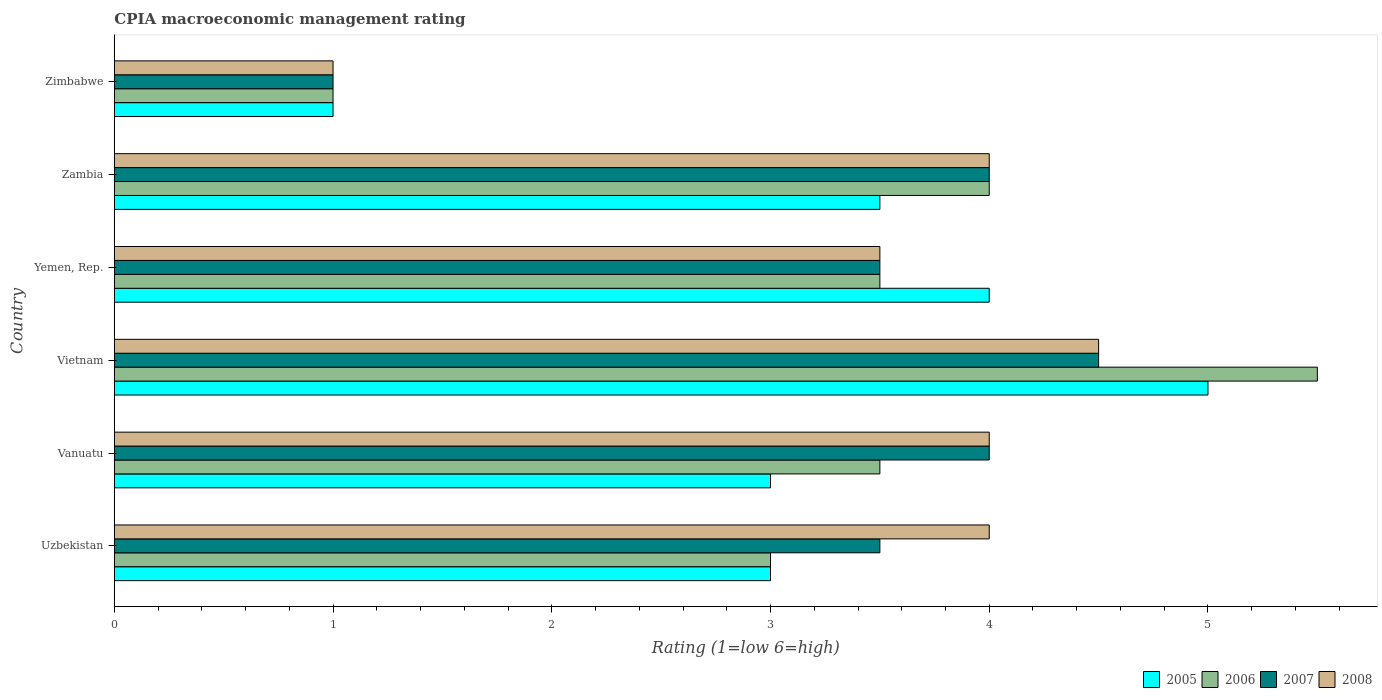How many groups of bars are there?
Offer a very short reply. 6. Are the number of bars per tick equal to the number of legend labels?
Keep it short and to the point. Yes. How many bars are there on the 2nd tick from the bottom?
Ensure brevity in your answer.  4. What is the label of the 3rd group of bars from the top?
Offer a terse response. Yemen, Rep. What is the CPIA rating in 2008 in Uzbekistan?
Your answer should be very brief. 4. Across all countries, what is the maximum CPIA rating in 2005?
Ensure brevity in your answer.  5. Across all countries, what is the minimum CPIA rating in 2006?
Give a very brief answer. 1. In which country was the CPIA rating in 2005 maximum?
Provide a succinct answer. Vietnam. In which country was the CPIA rating in 2006 minimum?
Provide a succinct answer. Zimbabwe. What is the difference between the CPIA rating in 2006 in Yemen, Rep. and that in Zambia?
Your response must be concise. -0.5. What is the average CPIA rating in 2007 per country?
Offer a very short reply. 3.42. What is the difference between the CPIA rating in 2006 and CPIA rating in 2008 in Uzbekistan?
Your answer should be compact. -1. Is the CPIA rating in 2006 in Uzbekistan less than that in Vanuatu?
Keep it short and to the point. Yes. What is the difference between the highest and the second highest CPIA rating in 2006?
Make the answer very short. 1.5. What is the difference between the highest and the lowest CPIA rating in 2005?
Offer a very short reply. 4. Is the sum of the CPIA rating in 2008 in Uzbekistan and Vanuatu greater than the maximum CPIA rating in 2005 across all countries?
Give a very brief answer. Yes. What does the 2nd bar from the top in Zimbabwe represents?
Provide a short and direct response. 2007. What does the 2nd bar from the bottom in Zambia represents?
Provide a short and direct response. 2006. Are all the bars in the graph horizontal?
Keep it short and to the point. Yes. Are the values on the major ticks of X-axis written in scientific E-notation?
Provide a succinct answer. No. Where does the legend appear in the graph?
Provide a short and direct response. Bottom right. How many legend labels are there?
Give a very brief answer. 4. What is the title of the graph?
Offer a very short reply. CPIA macroeconomic management rating. What is the label or title of the X-axis?
Your response must be concise. Rating (1=low 6=high). What is the Rating (1=low 6=high) in 2007 in Uzbekistan?
Make the answer very short. 3.5. What is the Rating (1=low 6=high) in 2006 in Vanuatu?
Your answer should be very brief. 3.5. What is the Rating (1=low 6=high) of 2007 in Vanuatu?
Provide a succinct answer. 4. What is the Rating (1=low 6=high) in 2008 in Vanuatu?
Your response must be concise. 4. What is the Rating (1=low 6=high) of 2005 in Vietnam?
Provide a short and direct response. 5. What is the Rating (1=low 6=high) of 2006 in Vietnam?
Provide a succinct answer. 5.5. What is the Rating (1=low 6=high) of 2007 in Vietnam?
Give a very brief answer. 4.5. What is the Rating (1=low 6=high) in 2008 in Vietnam?
Keep it short and to the point. 4.5. What is the Rating (1=low 6=high) in 2005 in Yemen, Rep.?
Keep it short and to the point. 4. What is the Rating (1=low 6=high) in 2006 in Yemen, Rep.?
Your answer should be very brief. 3.5. What is the Rating (1=low 6=high) of 2007 in Yemen, Rep.?
Provide a short and direct response. 3.5. What is the Rating (1=low 6=high) in 2007 in Zambia?
Make the answer very short. 4. What is the Rating (1=low 6=high) of 2008 in Zambia?
Keep it short and to the point. 4. What is the Rating (1=low 6=high) of 2005 in Zimbabwe?
Your response must be concise. 1. What is the Rating (1=low 6=high) of 2007 in Zimbabwe?
Offer a terse response. 1. What is the Rating (1=low 6=high) of 2008 in Zimbabwe?
Provide a short and direct response. 1. Across all countries, what is the maximum Rating (1=low 6=high) of 2005?
Your answer should be compact. 5. Across all countries, what is the maximum Rating (1=low 6=high) in 2008?
Keep it short and to the point. 4.5. Across all countries, what is the minimum Rating (1=low 6=high) in 2007?
Offer a very short reply. 1. Across all countries, what is the minimum Rating (1=low 6=high) of 2008?
Offer a very short reply. 1. What is the total Rating (1=low 6=high) of 2008 in the graph?
Provide a succinct answer. 21. What is the difference between the Rating (1=low 6=high) in 2005 in Uzbekistan and that in Vanuatu?
Provide a succinct answer. 0. What is the difference between the Rating (1=low 6=high) of 2006 in Uzbekistan and that in Vanuatu?
Provide a succinct answer. -0.5. What is the difference between the Rating (1=low 6=high) of 2007 in Uzbekistan and that in Vanuatu?
Your answer should be very brief. -0.5. What is the difference between the Rating (1=low 6=high) in 2008 in Uzbekistan and that in Vanuatu?
Make the answer very short. 0. What is the difference between the Rating (1=low 6=high) in 2006 in Uzbekistan and that in Vietnam?
Offer a very short reply. -2.5. What is the difference between the Rating (1=low 6=high) of 2006 in Uzbekistan and that in Yemen, Rep.?
Your answer should be very brief. -0.5. What is the difference between the Rating (1=low 6=high) of 2005 in Uzbekistan and that in Zambia?
Make the answer very short. -0.5. What is the difference between the Rating (1=low 6=high) of 2006 in Uzbekistan and that in Zambia?
Offer a very short reply. -1. What is the difference between the Rating (1=low 6=high) of 2005 in Uzbekistan and that in Zimbabwe?
Your answer should be very brief. 2. What is the difference between the Rating (1=low 6=high) of 2007 in Uzbekistan and that in Zimbabwe?
Your answer should be compact. 2.5. What is the difference between the Rating (1=low 6=high) in 2008 in Uzbekistan and that in Zimbabwe?
Your answer should be compact. 3. What is the difference between the Rating (1=low 6=high) in 2005 in Vanuatu and that in Yemen, Rep.?
Ensure brevity in your answer.  -1. What is the difference between the Rating (1=low 6=high) of 2005 in Vanuatu and that in Zambia?
Make the answer very short. -0.5. What is the difference between the Rating (1=low 6=high) of 2007 in Vanuatu and that in Zambia?
Ensure brevity in your answer.  0. What is the difference between the Rating (1=low 6=high) in 2008 in Vanuatu and that in Zambia?
Offer a very short reply. 0. What is the difference between the Rating (1=low 6=high) in 2005 in Vanuatu and that in Zimbabwe?
Ensure brevity in your answer.  2. What is the difference between the Rating (1=low 6=high) in 2006 in Vanuatu and that in Zimbabwe?
Make the answer very short. 2.5. What is the difference between the Rating (1=low 6=high) of 2008 in Vanuatu and that in Zimbabwe?
Make the answer very short. 3. What is the difference between the Rating (1=low 6=high) of 2007 in Vietnam and that in Yemen, Rep.?
Your answer should be compact. 1. What is the difference between the Rating (1=low 6=high) of 2007 in Vietnam and that in Zambia?
Keep it short and to the point. 0.5. What is the difference between the Rating (1=low 6=high) in 2008 in Vietnam and that in Zambia?
Provide a succinct answer. 0.5. What is the difference between the Rating (1=low 6=high) in 2006 in Vietnam and that in Zimbabwe?
Ensure brevity in your answer.  4.5. What is the difference between the Rating (1=low 6=high) in 2008 in Vietnam and that in Zimbabwe?
Provide a short and direct response. 3.5. What is the difference between the Rating (1=low 6=high) in 2008 in Yemen, Rep. and that in Zambia?
Your answer should be very brief. -0.5. What is the difference between the Rating (1=low 6=high) in 2007 in Yemen, Rep. and that in Zimbabwe?
Offer a terse response. 2.5. What is the difference between the Rating (1=low 6=high) in 2008 in Yemen, Rep. and that in Zimbabwe?
Your response must be concise. 2.5. What is the difference between the Rating (1=low 6=high) in 2005 in Uzbekistan and the Rating (1=low 6=high) in 2007 in Vanuatu?
Your response must be concise. -1. What is the difference between the Rating (1=low 6=high) in 2006 in Uzbekistan and the Rating (1=low 6=high) in 2007 in Vanuatu?
Provide a succinct answer. -1. What is the difference between the Rating (1=low 6=high) of 2007 in Uzbekistan and the Rating (1=low 6=high) of 2008 in Vanuatu?
Offer a very short reply. -0.5. What is the difference between the Rating (1=low 6=high) of 2005 in Uzbekistan and the Rating (1=low 6=high) of 2007 in Vietnam?
Offer a terse response. -1.5. What is the difference between the Rating (1=low 6=high) in 2006 in Uzbekistan and the Rating (1=low 6=high) in 2007 in Vietnam?
Offer a very short reply. -1.5. What is the difference between the Rating (1=low 6=high) of 2005 in Uzbekistan and the Rating (1=low 6=high) of 2007 in Yemen, Rep.?
Give a very brief answer. -0.5. What is the difference between the Rating (1=low 6=high) of 2005 in Uzbekistan and the Rating (1=low 6=high) of 2008 in Yemen, Rep.?
Give a very brief answer. -0.5. What is the difference between the Rating (1=low 6=high) in 2006 in Uzbekistan and the Rating (1=low 6=high) in 2007 in Yemen, Rep.?
Provide a succinct answer. -0.5. What is the difference between the Rating (1=low 6=high) of 2007 in Uzbekistan and the Rating (1=low 6=high) of 2008 in Yemen, Rep.?
Your answer should be very brief. 0. What is the difference between the Rating (1=low 6=high) of 2005 in Uzbekistan and the Rating (1=low 6=high) of 2008 in Zambia?
Give a very brief answer. -1. What is the difference between the Rating (1=low 6=high) of 2006 in Uzbekistan and the Rating (1=low 6=high) of 2008 in Zambia?
Keep it short and to the point. -1. What is the difference between the Rating (1=low 6=high) of 2007 in Uzbekistan and the Rating (1=low 6=high) of 2008 in Zambia?
Your answer should be very brief. -0.5. What is the difference between the Rating (1=low 6=high) in 2005 in Uzbekistan and the Rating (1=low 6=high) in 2007 in Zimbabwe?
Provide a short and direct response. 2. What is the difference between the Rating (1=low 6=high) of 2005 in Uzbekistan and the Rating (1=low 6=high) of 2008 in Zimbabwe?
Your answer should be very brief. 2. What is the difference between the Rating (1=low 6=high) of 2006 in Uzbekistan and the Rating (1=low 6=high) of 2007 in Zimbabwe?
Give a very brief answer. 2. What is the difference between the Rating (1=low 6=high) of 2007 in Uzbekistan and the Rating (1=low 6=high) of 2008 in Zimbabwe?
Ensure brevity in your answer.  2.5. What is the difference between the Rating (1=low 6=high) of 2005 in Vanuatu and the Rating (1=low 6=high) of 2007 in Vietnam?
Offer a very short reply. -1.5. What is the difference between the Rating (1=low 6=high) of 2005 in Vanuatu and the Rating (1=low 6=high) of 2008 in Vietnam?
Give a very brief answer. -1.5. What is the difference between the Rating (1=low 6=high) of 2005 in Vanuatu and the Rating (1=low 6=high) of 2006 in Yemen, Rep.?
Your answer should be very brief. -0.5. What is the difference between the Rating (1=low 6=high) in 2006 in Vanuatu and the Rating (1=low 6=high) in 2007 in Yemen, Rep.?
Make the answer very short. 0. What is the difference between the Rating (1=low 6=high) in 2006 in Vanuatu and the Rating (1=low 6=high) in 2008 in Yemen, Rep.?
Provide a short and direct response. 0. What is the difference between the Rating (1=low 6=high) in 2007 in Vanuatu and the Rating (1=low 6=high) in 2008 in Yemen, Rep.?
Offer a terse response. 0.5. What is the difference between the Rating (1=low 6=high) of 2006 in Vanuatu and the Rating (1=low 6=high) of 2008 in Zimbabwe?
Make the answer very short. 2.5. What is the difference between the Rating (1=low 6=high) of 2007 in Vanuatu and the Rating (1=low 6=high) of 2008 in Zimbabwe?
Provide a short and direct response. 3. What is the difference between the Rating (1=low 6=high) of 2005 in Vietnam and the Rating (1=low 6=high) of 2007 in Yemen, Rep.?
Your answer should be compact. 1.5. What is the difference between the Rating (1=low 6=high) of 2006 in Vietnam and the Rating (1=low 6=high) of 2007 in Yemen, Rep.?
Your answer should be compact. 2. What is the difference between the Rating (1=low 6=high) in 2006 in Vietnam and the Rating (1=low 6=high) in 2008 in Yemen, Rep.?
Your response must be concise. 2. What is the difference between the Rating (1=low 6=high) of 2007 in Vietnam and the Rating (1=low 6=high) of 2008 in Yemen, Rep.?
Provide a succinct answer. 1. What is the difference between the Rating (1=low 6=high) of 2006 in Vietnam and the Rating (1=low 6=high) of 2007 in Zambia?
Provide a short and direct response. 1.5. What is the difference between the Rating (1=low 6=high) of 2006 in Vietnam and the Rating (1=low 6=high) of 2007 in Zimbabwe?
Your answer should be compact. 4.5. What is the difference between the Rating (1=low 6=high) of 2005 in Yemen, Rep. and the Rating (1=low 6=high) of 2006 in Zambia?
Offer a very short reply. 0. What is the difference between the Rating (1=low 6=high) of 2005 in Yemen, Rep. and the Rating (1=low 6=high) of 2007 in Zambia?
Your response must be concise. 0. What is the difference between the Rating (1=low 6=high) in 2006 in Yemen, Rep. and the Rating (1=low 6=high) in 2007 in Zambia?
Keep it short and to the point. -0.5. What is the difference between the Rating (1=low 6=high) in 2006 in Yemen, Rep. and the Rating (1=low 6=high) in 2008 in Zambia?
Ensure brevity in your answer.  -0.5. What is the difference between the Rating (1=low 6=high) of 2007 in Yemen, Rep. and the Rating (1=low 6=high) of 2008 in Zambia?
Offer a terse response. -0.5. What is the difference between the Rating (1=low 6=high) in 2005 in Yemen, Rep. and the Rating (1=low 6=high) in 2007 in Zimbabwe?
Your answer should be very brief. 3. What is the difference between the Rating (1=low 6=high) of 2005 in Yemen, Rep. and the Rating (1=low 6=high) of 2008 in Zimbabwe?
Your response must be concise. 3. What is the difference between the Rating (1=low 6=high) of 2006 in Yemen, Rep. and the Rating (1=low 6=high) of 2008 in Zimbabwe?
Provide a short and direct response. 2.5. What is the difference between the Rating (1=low 6=high) in 2005 in Zambia and the Rating (1=low 6=high) in 2006 in Zimbabwe?
Offer a very short reply. 2.5. What is the difference between the Rating (1=low 6=high) in 2005 in Zambia and the Rating (1=low 6=high) in 2008 in Zimbabwe?
Offer a terse response. 2.5. What is the difference between the Rating (1=low 6=high) of 2006 in Zambia and the Rating (1=low 6=high) of 2007 in Zimbabwe?
Offer a very short reply. 3. What is the difference between the Rating (1=low 6=high) in 2007 in Zambia and the Rating (1=low 6=high) in 2008 in Zimbabwe?
Your answer should be compact. 3. What is the average Rating (1=low 6=high) of 2005 per country?
Ensure brevity in your answer.  3.25. What is the average Rating (1=low 6=high) of 2006 per country?
Offer a terse response. 3.42. What is the average Rating (1=low 6=high) of 2007 per country?
Give a very brief answer. 3.42. What is the difference between the Rating (1=low 6=high) in 2005 and Rating (1=low 6=high) in 2006 in Uzbekistan?
Your answer should be very brief. 0. What is the difference between the Rating (1=low 6=high) in 2005 and Rating (1=low 6=high) in 2008 in Uzbekistan?
Your answer should be very brief. -1. What is the difference between the Rating (1=low 6=high) of 2006 and Rating (1=low 6=high) of 2007 in Uzbekistan?
Ensure brevity in your answer.  -0.5. What is the difference between the Rating (1=low 6=high) of 2006 and Rating (1=low 6=high) of 2008 in Uzbekistan?
Make the answer very short. -1. What is the difference between the Rating (1=low 6=high) of 2007 and Rating (1=low 6=high) of 2008 in Uzbekistan?
Ensure brevity in your answer.  -0.5. What is the difference between the Rating (1=low 6=high) of 2005 and Rating (1=low 6=high) of 2007 in Vanuatu?
Give a very brief answer. -1. What is the difference between the Rating (1=low 6=high) of 2005 and Rating (1=low 6=high) of 2008 in Vanuatu?
Ensure brevity in your answer.  -1. What is the difference between the Rating (1=low 6=high) in 2006 and Rating (1=low 6=high) in 2007 in Vanuatu?
Provide a succinct answer. -0.5. What is the difference between the Rating (1=low 6=high) in 2007 and Rating (1=low 6=high) in 2008 in Vanuatu?
Ensure brevity in your answer.  0. What is the difference between the Rating (1=low 6=high) in 2005 and Rating (1=low 6=high) in 2007 in Vietnam?
Make the answer very short. 0.5. What is the difference between the Rating (1=low 6=high) of 2007 and Rating (1=low 6=high) of 2008 in Vietnam?
Keep it short and to the point. 0. What is the difference between the Rating (1=low 6=high) in 2005 and Rating (1=low 6=high) in 2007 in Yemen, Rep.?
Offer a very short reply. 0.5. What is the difference between the Rating (1=low 6=high) of 2005 and Rating (1=low 6=high) of 2008 in Yemen, Rep.?
Give a very brief answer. 0.5. What is the difference between the Rating (1=low 6=high) of 2006 and Rating (1=low 6=high) of 2007 in Yemen, Rep.?
Provide a succinct answer. 0. What is the difference between the Rating (1=low 6=high) in 2006 and Rating (1=low 6=high) in 2008 in Yemen, Rep.?
Keep it short and to the point. 0. What is the difference between the Rating (1=low 6=high) of 2007 and Rating (1=low 6=high) of 2008 in Yemen, Rep.?
Your response must be concise. 0. What is the difference between the Rating (1=low 6=high) of 2005 and Rating (1=low 6=high) of 2006 in Zambia?
Your response must be concise. -0.5. What is the difference between the Rating (1=low 6=high) of 2005 and Rating (1=low 6=high) of 2007 in Zambia?
Make the answer very short. -0.5. What is the difference between the Rating (1=low 6=high) of 2005 and Rating (1=low 6=high) of 2008 in Zambia?
Your response must be concise. -0.5. What is the difference between the Rating (1=low 6=high) in 2005 and Rating (1=low 6=high) in 2006 in Zimbabwe?
Keep it short and to the point. 0. What is the difference between the Rating (1=low 6=high) of 2005 and Rating (1=low 6=high) of 2008 in Zimbabwe?
Provide a short and direct response. 0. What is the difference between the Rating (1=low 6=high) of 2006 and Rating (1=low 6=high) of 2007 in Zimbabwe?
Make the answer very short. 0. What is the difference between the Rating (1=low 6=high) in 2006 and Rating (1=low 6=high) in 2008 in Zimbabwe?
Your answer should be very brief. 0. What is the ratio of the Rating (1=low 6=high) in 2006 in Uzbekistan to that in Vanuatu?
Keep it short and to the point. 0.86. What is the ratio of the Rating (1=low 6=high) of 2007 in Uzbekistan to that in Vanuatu?
Make the answer very short. 0.88. What is the ratio of the Rating (1=low 6=high) of 2006 in Uzbekistan to that in Vietnam?
Provide a short and direct response. 0.55. What is the ratio of the Rating (1=low 6=high) of 2008 in Uzbekistan to that in Vietnam?
Offer a terse response. 0.89. What is the ratio of the Rating (1=low 6=high) of 2006 in Uzbekistan to that in Yemen, Rep.?
Make the answer very short. 0.86. What is the ratio of the Rating (1=low 6=high) in 2008 in Uzbekistan to that in Yemen, Rep.?
Ensure brevity in your answer.  1.14. What is the ratio of the Rating (1=low 6=high) of 2005 in Uzbekistan to that in Zimbabwe?
Your answer should be very brief. 3. What is the ratio of the Rating (1=low 6=high) of 2006 in Vanuatu to that in Vietnam?
Provide a short and direct response. 0.64. What is the ratio of the Rating (1=low 6=high) in 2007 in Vanuatu to that in Vietnam?
Make the answer very short. 0.89. What is the ratio of the Rating (1=low 6=high) of 2005 in Vanuatu to that in Yemen, Rep.?
Your answer should be very brief. 0.75. What is the ratio of the Rating (1=low 6=high) in 2006 in Vanuatu to that in Yemen, Rep.?
Make the answer very short. 1. What is the ratio of the Rating (1=low 6=high) of 2008 in Vanuatu to that in Yemen, Rep.?
Offer a terse response. 1.14. What is the ratio of the Rating (1=low 6=high) of 2005 in Vanuatu to that in Zambia?
Provide a short and direct response. 0.86. What is the ratio of the Rating (1=low 6=high) of 2006 in Vanuatu to that in Zambia?
Your answer should be very brief. 0.88. What is the ratio of the Rating (1=low 6=high) in 2008 in Vanuatu to that in Zambia?
Provide a short and direct response. 1. What is the ratio of the Rating (1=low 6=high) in 2006 in Vanuatu to that in Zimbabwe?
Make the answer very short. 3.5. What is the ratio of the Rating (1=low 6=high) in 2008 in Vanuatu to that in Zimbabwe?
Provide a short and direct response. 4. What is the ratio of the Rating (1=low 6=high) in 2006 in Vietnam to that in Yemen, Rep.?
Keep it short and to the point. 1.57. What is the ratio of the Rating (1=low 6=high) in 2005 in Vietnam to that in Zambia?
Give a very brief answer. 1.43. What is the ratio of the Rating (1=low 6=high) in 2006 in Vietnam to that in Zambia?
Your answer should be compact. 1.38. What is the ratio of the Rating (1=low 6=high) in 2007 in Vietnam to that in Zambia?
Offer a very short reply. 1.12. What is the ratio of the Rating (1=low 6=high) in 2008 in Vietnam to that in Zambia?
Your answer should be very brief. 1.12. What is the ratio of the Rating (1=low 6=high) in 2005 in Vietnam to that in Zimbabwe?
Your answer should be very brief. 5. What is the ratio of the Rating (1=low 6=high) of 2007 in Vietnam to that in Zimbabwe?
Ensure brevity in your answer.  4.5. What is the ratio of the Rating (1=low 6=high) in 2008 in Vietnam to that in Zimbabwe?
Keep it short and to the point. 4.5. What is the ratio of the Rating (1=low 6=high) in 2006 in Yemen, Rep. to that in Zambia?
Your answer should be very brief. 0.88. What is the ratio of the Rating (1=low 6=high) in 2005 in Yemen, Rep. to that in Zimbabwe?
Keep it short and to the point. 4. What is the ratio of the Rating (1=low 6=high) in 2007 in Yemen, Rep. to that in Zimbabwe?
Ensure brevity in your answer.  3.5. What is the ratio of the Rating (1=low 6=high) of 2006 in Zambia to that in Zimbabwe?
Give a very brief answer. 4. What is the ratio of the Rating (1=low 6=high) in 2007 in Zambia to that in Zimbabwe?
Your response must be concise. 4. What is the ratio of the Rating (1=low 6=high) of 2008 in Zambia to that in Zimbabwe?
Offer a very short reply. 4. What is the difference between the highest and the second highest Rating (1=low 6=high) in 2006?
Ensure brevity in your answer.  1.5. What is the difference between the highest and the lowest Rating (1=low 6=high) in 2008?
Provide a short and direct response. 3.5. 